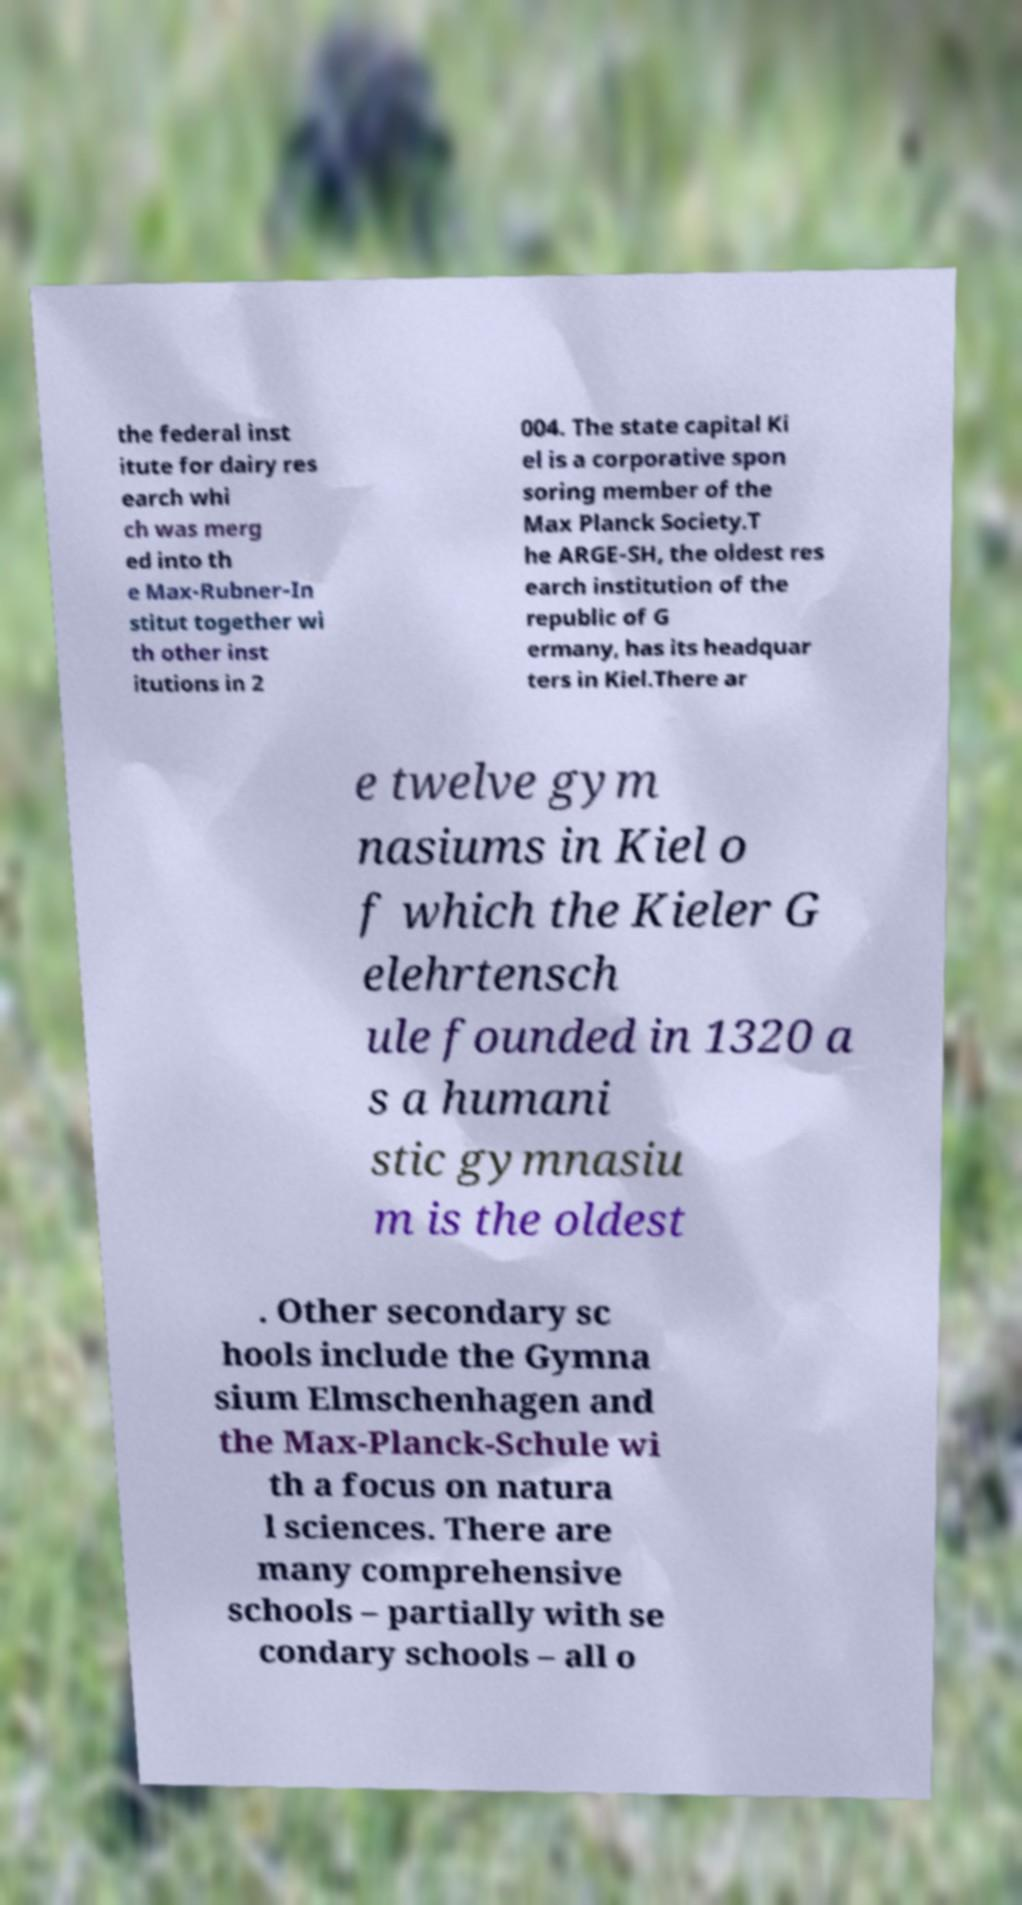Could you assist in decoding the text presented in this image and type it out clearly? the federal inst itute for dairy res earch whi ch was merg ed into th e Max-Rubner-In stitut together wi th other inst itutions in 2 004. The state capital Ki el is a corporative spon soring member of the Max Planck Society.T he ARGE-SH, the oldest res earch institution of the republic of G ermany, has its headquar ters in Kiel.There ar e twelve gym nasiums in Kiel o f which the Kieler G elehrtensch ule founded in 1320 a s a humani stic gymnasiu m is the oldest . Other secondary sc hools include the Gymna sium Elmschenhagen and the Max-Planck-Schule wi th a focus on natura l sciences. There are many comprehensive schools – partially with se condary schools – all o 